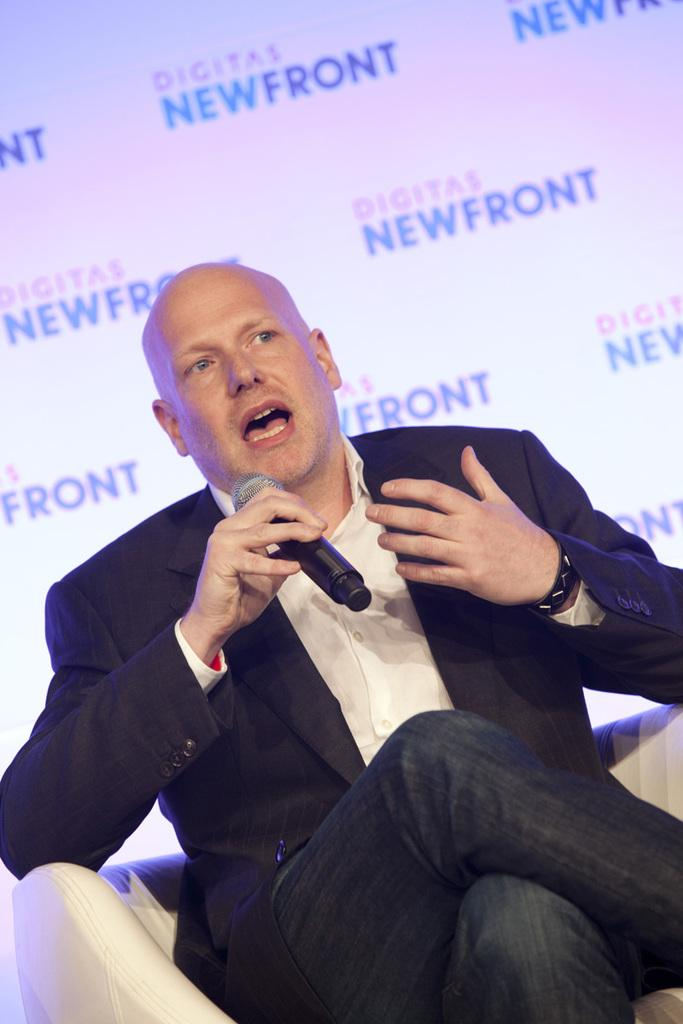Who is the main subject in the image? There is a man in the image. What is the man doing in the image? The man is sitting on a chair. What object is the man holding in the image? The man is holding a microphone. What type of orange can be seen growing in the wilderness in the image? There is no orange or wilderness present in the image; it features a man sitting on a chair and holding a microphone. 